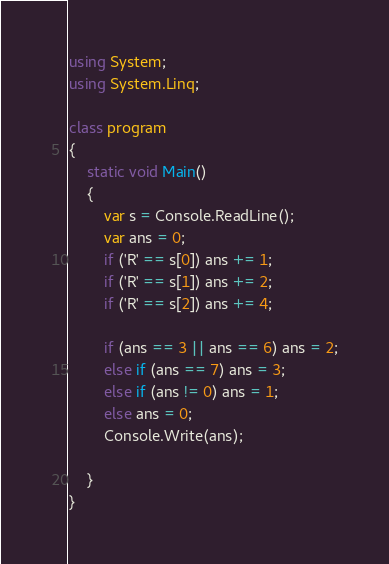Convert code to text. <code><loc_0><loc_0><loc_500><loc_500><_C#_>using System;
using System.Linq;
 
class program
{
    static void Main()
    {
        var s = Console.ReadLine();
        var ans = 0;
        if ('R' == s[0]) ans += 1;
        if ('R' == s[1]) ans += 2;
        if ('R' == s[2]) ans += 4;
      
        if (ans == 3 || ans == 6) ans = 2;
        else if (ans == 7) ans = 3;
        else if (ans != 0) ans = 1;
        else ans = 0;
        Console.Write(ans);
                
    }
}</code> 